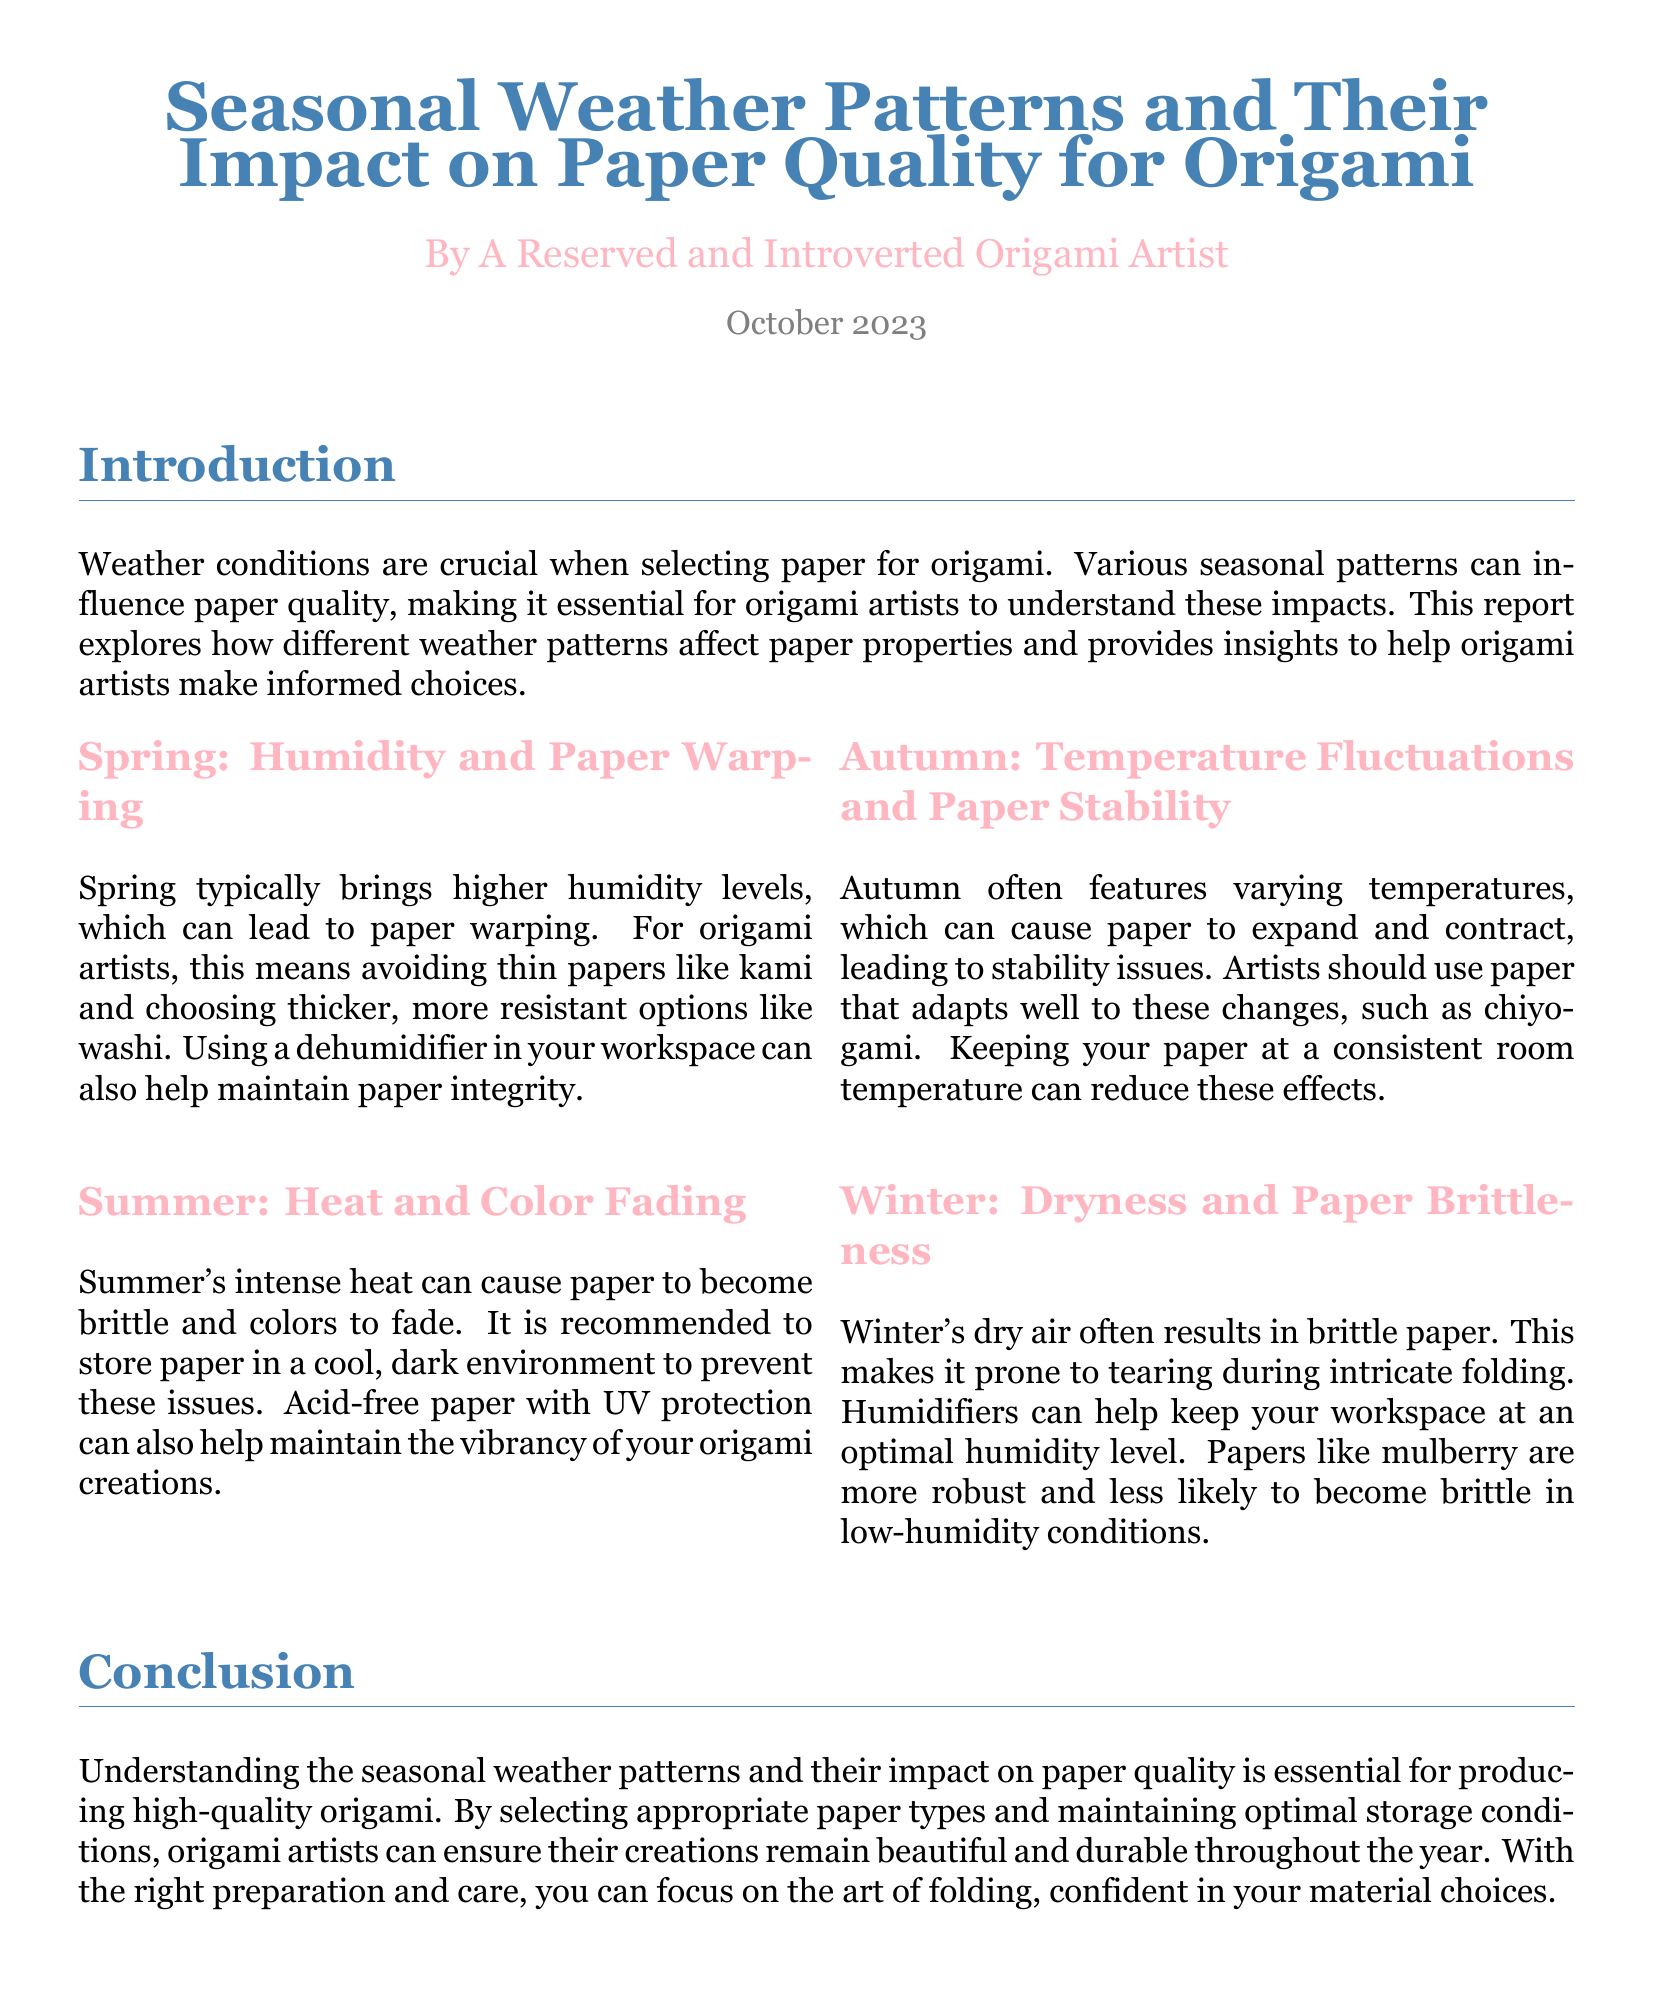What is the title of the document? The title can be found at the beginning of the document and is presented in large text.
Answer: Seasonal Weather Patterns and Their Impact on Paper Quality for Origami Who is the author of the report? The author's name is listed below the title in smaller text.
Answer: A Reserved and Introverted Origami Artist What season is associated with higher humidity? The section on Spring discusses humidity levels, indicating that Spring has higher humidity.
Answer: Spring What type of paper is recommended to avoid warping in Spring? The report specifies avoiding thin papers and suggests using thicker, more resistant options.
Answer: Washi What issue does Summer's heat cause for paper? The section about Summer highlights specific issues that arise from intense heat impacting paper quality.
Answer: Brittleness Which paper type is suggested for Autumn temperature fluctuations? The Autumn section mentions a specific paper type that adapts well to expanding and contracting.
Answer: Chiyogami What seasonal condition leads to paper brittleness? Winter's dryness is specifically associated with causing brittleness in paper.
Answer: Dryness What can be used in Winter to maintain paper integrity? The report suggests using a specific device to help with humidity in the Winter.
Answer: Humidifiers Which month is noted for the report's publication? The date is located at the end of the introductory section.
Answer: October 2023 